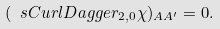<formula> <loc_0><loc_0><loc_500><loc_500>( \ s C u r l D a g g e r _ { 2 , 0 } \chi ) _ { A A ^ { \prime } } = 0 .</formula> 